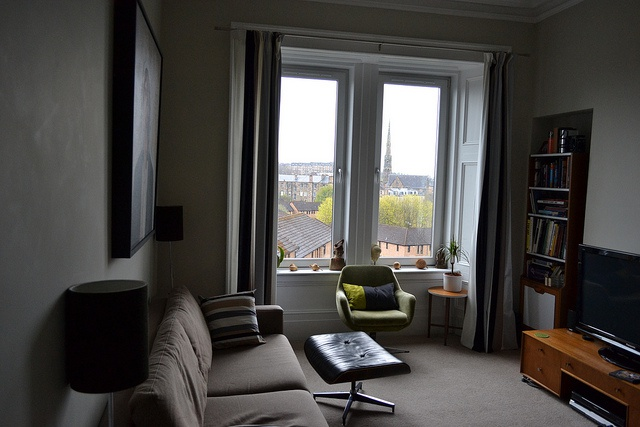Describe the objects in this image and their specific colors. I can see couch in black and gray tones, tv in black, gray, and darkgray tones, chair in black, gray, darkgray, and darkgreen tones, book in black, gray, and maroon tones, and potted plant in black, gray, darkgray, and darkgreen tones in this image. 